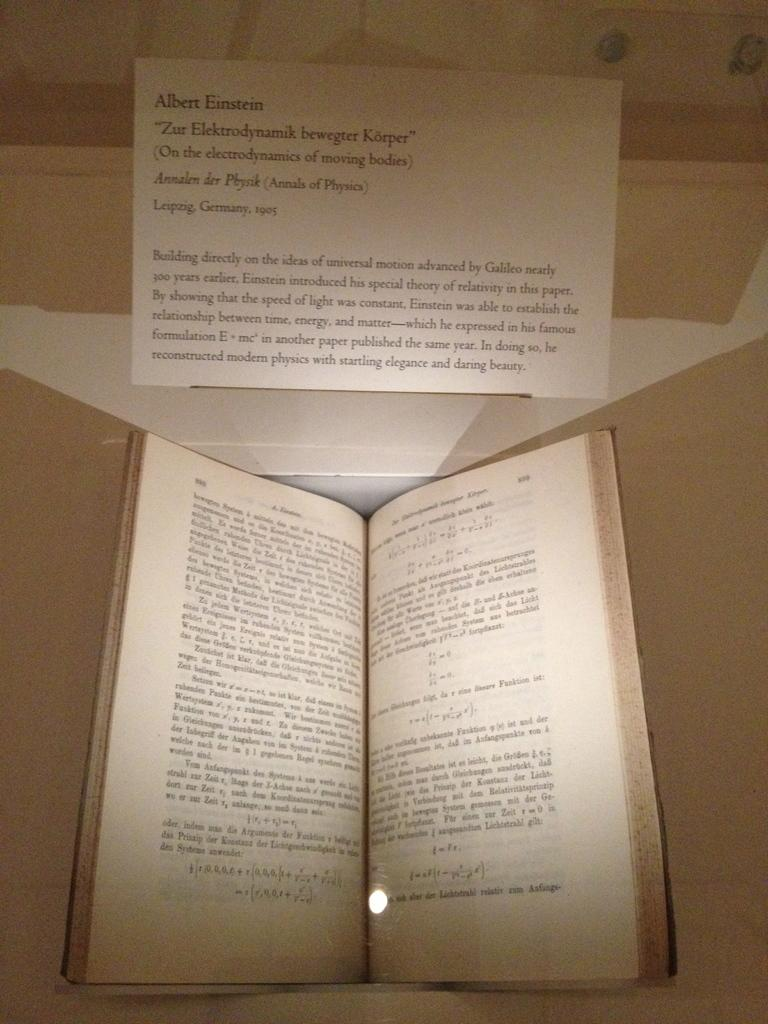<image>
Share a concise interpretation of the image provided. A book with text sits open with a card above it that talks about Albert Einstein. 